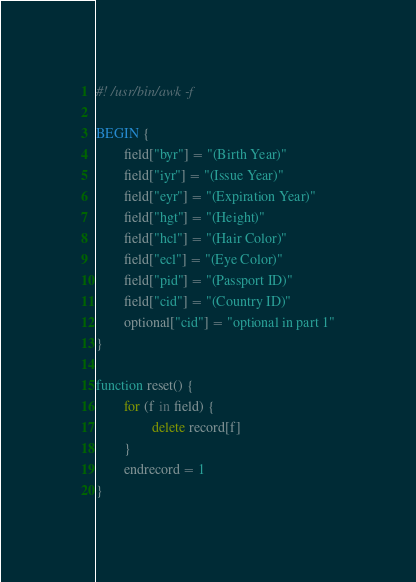Convert code to text. <code><loc_0><loc_0><loc_500><loc_500><_Awk_>#! /usr/bin/awk -f

BEGIN {
        field["byr"] = "(Birth Year)"
        field["iyr"] = "(Issue Year)"
        field["eyr"] = "(Expiration Year)"
        field["hgt"] = "(Height)"
        field["hcl"] = "(Hair Color)"
        field["ecl"] = "(Eye Color)"
        field["pid"] = "(Passport ID)"
        field["cid"] = "(Country ID)"
        optional["cid"] = "optional in part 1"
}

function reset() {
        for (f in field) {
                delete record[f]
        }
        endrecord = 1
}
</code> 